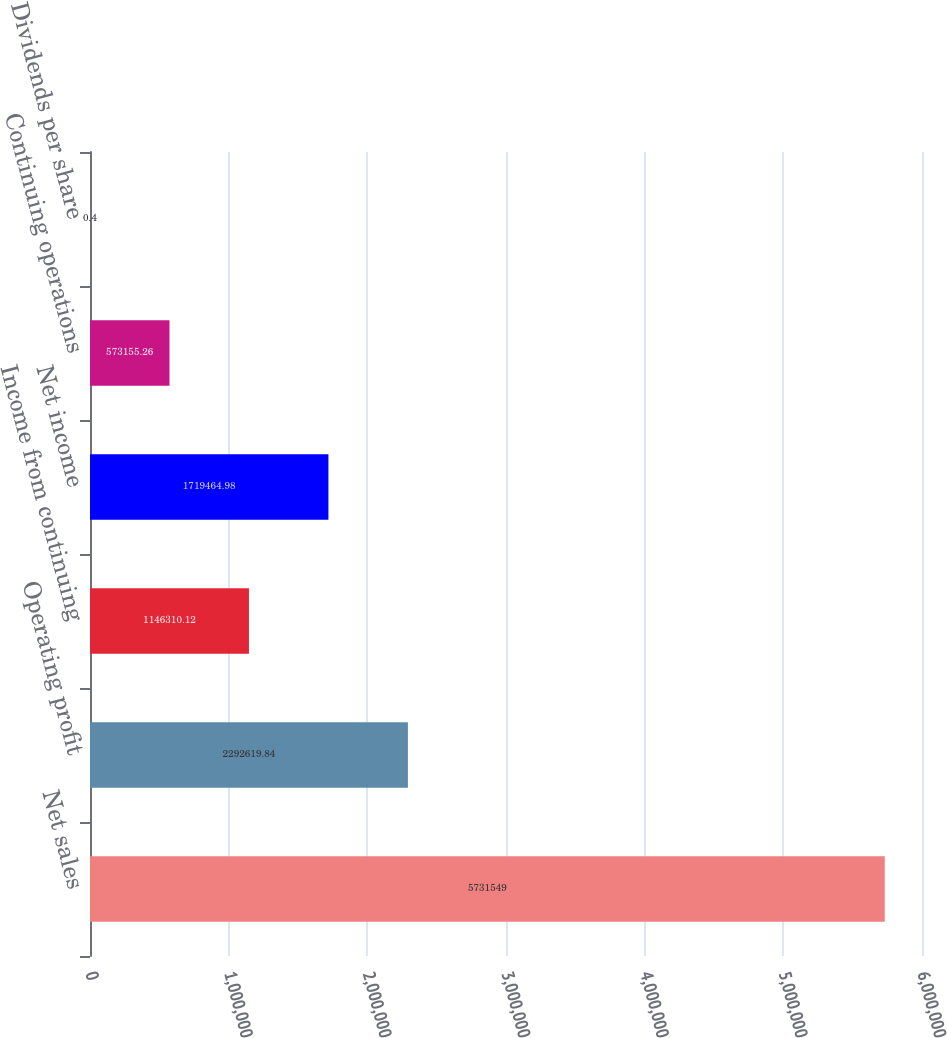<chart> <loc_0><loc_0><loc_500><loc_500><bar_chart><fcel>Net sales<fcel>Operating profit<fcel>Income from continuing<fcel>Net income<fcel>Continuing operations<fcel>Dividends per share<nl><fcel>5.73155e+06<fcel>2.29262e+06<fcel>1.14631e+06<fcel>1.71946e+06<fcel>573155<fcel>0.4<nl></chart> 